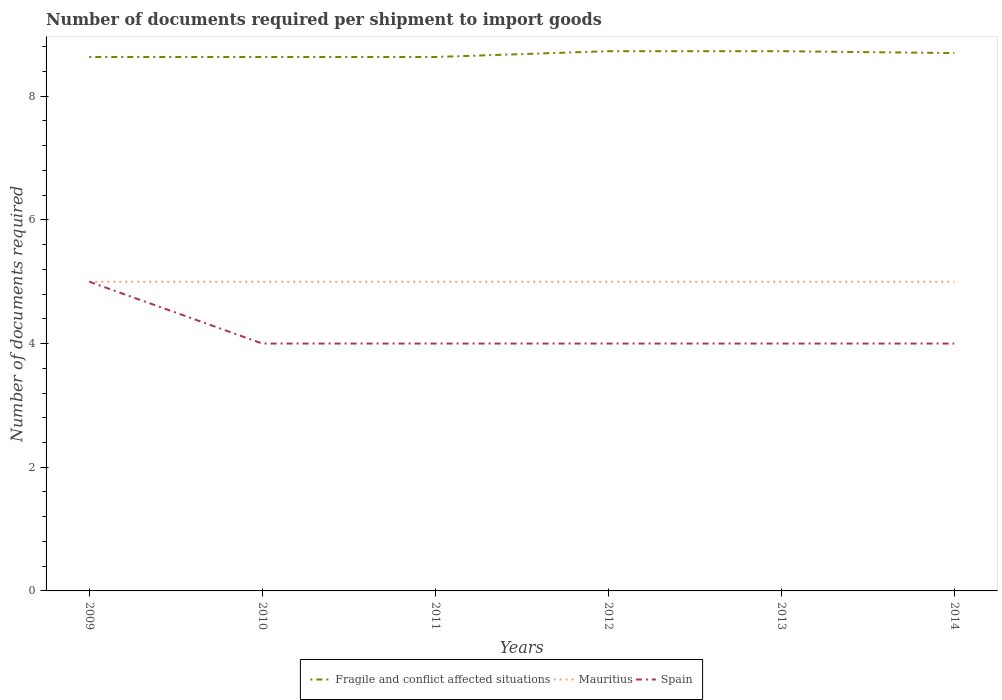How many different coloured lines are there?
Provide a succinct answer. 3. Across all years, what is the maximum number of documents required per shipment to import goods in Mauritius?
Your answer should be compact. 5. What is the difference between the highest and the second highest number of documents required per shipment to import goods in Mauritius?
Your answer should be compact. 0. What is the difference between the highest and the lowest number of documents required per shipment to import goods in Spain?
Provide a succinct answer. 1. How many years are there in the graph?
Make the answer very short. 6. Are the values on the major ticks of Y-axis written in scientific E-notation?
Your answer should be compact. No. Does the graph contain any zero values?
Offer a very short reply. No. Does the graph contain grids?
Offer a very short reply. No. How many legend labels are there?
Your response must be concise. 3. How are the legend labels stacked?
Provide a succinct answer. Horizontal. What is the title of the graph?
Your answer should be very brief. Number of documents required per shipment to import goods. What is the label or title of the X-axis?
Your response must be concise. Years. What is the label or title of the Y-axis?
Provide a succinct answer. Number of documents required. What is the Number of documents required in Fragile and conflict affected situations in 2009?
Provide a succinct answer. 8.63. What is the Number of documents required of Fragile and conflict affected situations in 2010?
Offer a terse response. 8.63. What is the Number of documents required of Spain in 2010?
Ensure brevity in your answer.  4. What is the Number of documents required in Fragile and conflict affected situations in 2011?
Offer a very short reply. 8.63. What is the Number of documents required of Mauritius in 2011?
Offer a terse response. 5. What is the Number of documents required of Fragile and conflict affected situations in 2012?
Offer a terse response. 8.73. What is the Number of documents required in Mauritius in 2012?
Your response must be concise. 5. What is the Number of documents required in Spain in 2012?
Offer a very short reply. 4. What is the Number of documents required of Fragile and conflict affected situations in 2013?
Offer a terse response. 8.73. What is the Number of documents required in Spain in 2013?
Offer a terse response. 4. What is the Number of documents required in Fragile and conflict affected situations in 2014?
Make the answer very short. 8.7. What is the Number of documents required of Spain in 2014?
Ensure brevity in your answer.  4. Across all years, what is the maximum Number of documents required in Fragile and conflict affected situations?
Ensure brevity in your answer.  8.73. Across all years, what is the maximum Number of documents required in Mauritius?
Provide a succinct answer. 5. Across all years, what is the minimum Number of documents required of Fragile and conflict affected situations?
Offer a very short reply. 8.63. What is the total Number of documents required in Fragile and conflict affected situations in the graph?
Your answer should be very brief. 52.05. What is the total Number of documents required of Mauritius in the graph?
Your answer should be compact. 30. What is the total Number of documents required in Spain in the graph?
Your answer should be very brief. 25. What is the difference between the Number of documents required in Mauritius in 2009 and that in 2010?
Provide a succinct answer. 0. What is the difference between the Number of documents required in Spain in 2009 and that in 2010?
Your answer should be compact. 1. What is the difference between the Number of documents required of Mauritius in 2009 and that in 2011?
Ensure brevity in your answer.  0. What is the difference between the Number of documents required in Fragile and conflict affected situations in 2009 and that in 2012?
Your answer should be compact. -0.09. What is the difference between the Number of documents required of Mauritius in 2009 and that in 2012?
Provide a succinct answer. 0. What is the difference between the Number of documents required of Spain in 2009 and that in 2012?
Give a very brief answer. 1. What is the difference between the Number of documents required of Fragile and conflict affected situations in 2009 and that in 2013?
Offer a very short reply. -0.09. What is the difference between the Number of documents required of Fragile and conflict affected situations in 2009 and that in 2014?
Provide a short and direct response. -0.06. What is the difference between the Number of documents required of Mauritius in 2010 and that in 2011?
Your response must be concise. 0. What is the difference between the Number of documents required in Spain in 2010 and that in 2011?
Make the answer very short. 0. What is the difference between the Number of documents required in Fragile and conflict affected situations in 2010 and that in 2012?
Make the answer very short. -0.09. What is the difference between the Number of documents required of Spain in 2010 and that in 2012?
Your answer should be very brief. 0. What is the difference between the Number of documents required in Fragile and conflict affected situations in 2010 and that in 2013?
Ensure brevity in your answer.  -0.09. What is the difference between the Number of documents required in Mauritius in 2010 and that in 2013?
Offer a very short reply. 0. What is the difference between the Number of documents required in Spain in 2010 and that in 2013?
Provide a succinct answer. 0. What is the difference between the Number of documents required of Fragile and conflict affected situations in 2010 and that in 2014?
Offer a very short reply. -0.06. What is the difference between the Number of documents required in Mauritius in 2010 and that in 2014?
Make the answer very short. 0. What is the difference between the Number of documents required of Spain in 2010 and that in 2014?
Offer a terse response. 0. What is the difference between the Number of documents required of Fragile and conflict affected situations in 2011 and that in 2012?
Your response must be concise. -0.09. What is the difference between the Number of documents required in Mauritius in 2011 and that in 2012?
Your answer should be compact. 0. What is the difference between the Number of documents required in Fragile and conflict affected situations in 2011 and that in 2013?
Your answer should be compact. -0.09. What is the difference between the Number of documents required in Mauritius in 2011 and that in 2013?
Ensure brevity in your answer.  0. What is the difference between the Number of documents required of Spain in 2011 and that in 2013?
Make the answer very short. 0. What is the difference between the Number of documents required in Fragile and conflict affected situations in 2011 and that in 2014?
Your response must be concise. -0.06. What is the difference between the Number of documents required in Mauritius in 2012 and that in 2013?
Ensure brevity in your answer.  0. What is the difference between the Number of documents required of Fragile and conflict affected situations in 2012 and that in 2014?
Give a very brief answer. 0.03. What is the difference between the Number of documents required in Mauritius in 2012 and that in 2014?
Offer a very short reply. 0. What is the difference between the Number of documents required of Fragile and conflict affected situations in 2013 and that in 2014?
Ensure brevity in your answer.  0.03. What is the difference between the Number of documents required of Mauritius in 2013 and that in 2014?
Make the answer very short. 0. What is the difference between the Number of documents required of Fragile and conflict affected situations in 2009 and the Number of documents required of Mauritius in 2010?
Your answer should be compact. 3.63. What is the difference between the Number of documents required in Fragile and conflict affected situations in 2009 and the Number of documents required in Spain in 2010?
Provide a succinct answer. 4.63. What is the difference between the Number of documents required in Mauritius in 2009 and the Number of documents required in Spain in 2010?
Make the answer very short. 1. What is the difference between the Number of documents required of Fragile and conflict affected situations in 2009 and the Number of documents required of Mauritius in 2011?
Your answer should be very brief. 3.63. What is the difference between the Number of documents required in Fragile and conflict affected situations in 2009 and the Number of documents required in Spain in 2011?
Your answer should be compact. 4.63. What is the difference between the Number of documents required in Mauritius in 2009 and the Number of documents required in Spain in 2011?
Your response must be concise. 1. What is the difference between the Number of documents required in Fragile and conflict affected situations in 2009 and the Number of documents required in Mauritius in 2012?
Ensure brevity in your answer.  3.63. What is the difference between the Number of documents required of Fragile and conflict affected situations in 2009 and the Number of documents required of Spain in 2012?
Provide a short and direct response. 4.63. What is the difference between the Number of documents required of Mauritius in 2009 and the Number of documents required of Spain in 2012?
Ensure brevity in your answer.  1. What is the difference between the Number of documents required of Fragile and conflict affected situations in 2009 and the Number of documents required of Mauritius in 2013?
Provide a succinct answer. 3.63. What is the difference between the Number of documents required in Fragile and conflict affected situations in 2009 and the Number of documents required in Spain in 2013?
Offer a very short reply. 4.63. What is the difference between the Number of documents required of Fragile and conflict affected situations in 2009 and the Number of documents required of Mauritius in 2014?
Your response must be concise. 3.63. What is the difference between the Number of documents required in Fragile and conflict affected situations in 2009 and the Number of documents required in Spain in 2014?
Make the answer very short. 4.63. What is the difference between the Number of documents required in Fragile and conflict affected situations in 2010 and the Number of documents required in Mauritius in 2011?
Make the answer very short. 3.63. What is the difference between the Number of documents required in Fragile and conflict affected situations in 2010 and the Number of documents required in Spain in 2011?
Ensure brevity in your answer.  4.63. What is the difference between the Number of documents required in Fragile and conflict affected situations in 2010 and the Number of documents required in Mauritius in 2012?
Your answer should be very brief. 3.63. What is the difference between the Number of documents required in Fragile and conflict affected situations in 2010 and the Number of documents required in Spain in 2012?
Ensure brevity in your answer.  4.63. What is the difference between the Number of documents required of Fragile and conflict affected situations in 2010 and the Number of documents required of Mauritius in 2013?
Your answer should be compact. 3.63. What is the difference between the Number of documents required of Fragile and conflict affected situations in 2010 and the Number of documents required of Spain in 2013?
Give a very brief answer. 4.63. What is the difference between the Number of documents required of Mauritius in 2010 and the Number of documents required of Spain in 2013?
Your answer should be very brief. 1. What is the difference between the Number of documents required of Fragile and conflict affected situations in 2010 and the Number of documents required of Mauritius in 2014?
Keep it short and to the point. 3.63. What is the difference between the Number of documents required in Fragile and conflict affected situations in 2010 and the Number of documents required in Spain in 2014?
Make the answer very short. 4.63. What is the difference between the Number of documents required of Mauritius in 2010 and the Number of documents required of Spain in 2014?
Offer a terse response. 1. What is the difference between the Number of documents required of Fragile and conflict affected situations in 2011 and the Number of documents required of Mauritius in 2012?
Provide a short and direct response. 3.63. What is the difference between the Number of documents required in Fragile and conflict affected situations in 2011 and the Number of documents required in Spain in 2012?
Provide a succinct answer. 4.63. What is the difference between the Number of documents required of Mauritius in 2011 and the Number of documents required of Spain in 2012?
Offer a very short reply. 1. What is the difference between the Number of documents required in Fragile and conflict affected situations in 2011 and the Number of documents required in Mauritius in 2013?
Your answer should be compact. 3.63. What is the difference between the Number of documents required of Fragile and conflict affected situations in 2011 and the Number of documents required of Spain in 2013?
Provide a succinct answer. 4.63. What is the difference between the Number of documents required of Mauritius in 2011 and the Number of documents required of Spain in 2013?
Ensure brevity in your answer.  1. What is the difference between the Number of documents required in Fragile and conflict affected situations in 2011 and the Number of documents required in Mauritius in 2014?
Offer a terse response. 3.63. What is the difference between the Number of documents required in Fragile and conflict affected situations in 2011 and the Number of documents required in Spain in 2014?
Your response must be concise. 4.63. What is the difference between the Number of documents required of Mauritius in 2011 and the Number of documents required of Spain in 2014?
Keep it short and to the point. 1. What is the difference between the Number of documents required in Fragile and conflict affected situations in 2012 and the Number of documents required in Mauritius in 2013?
Offer a very short reply. 3.73. What is the difference between the Number of documents required in Fragile and conflict affected situations in 2012 and the Number of documents required in Spain in 2013?
Your response must be concise. 4.73. What is the difference between the Number of documents required of Fragile and conflict affected situations in 2012 and the Number of documents required of Mauritius in 2014?
Give a very brief answer. 3.73. What is the difference between the Number of documents required of Fragile and conflict affected situations in 2012 and the Number of documents required of Spain in 2014?
Your response must be concise. 4.73. What is the difference between the Number of documents required of Mauritius in 2012 and the Number of documents required of Spain in 2014?
Your answer should be very brief. 1. What is the difference between the Number of documents required of Fragile and conflict affected situations in 2013 and the Number of documents required of Mauritius in 2014?
Your answer should be compact. 3.73. What is the difference between the Number of documents required in Fragile and conflict affected situations in 2013 and the Number of documents required in Spain in 2014?
Ensure brevity in your answer.  4.73. What is the difference between the Number of documents required in Mauritius in 2013 and the Number of documents required in Spain in 2014?
Provide a succinct answer. 1. What is the average Number of documents required in Fragile and conflict affected situations per year?
Keep it short and to the point. 8.68. What is the average Number of documents required in Spain per year?
Keep it short and to the point. 4.17. In the year 2009, what is the difference between the Number of documents required of Fragile and conflict affected situations and Number of documents required of Mauritius?
Provide a short and direct response. 3.63. In the year 2009, what is the difference between the Number of documents required of Fragile and conflict affected situations and Number of documents required of Spain?
Offer a terse response. 3.63. In the year 2009, what is the difference between the Number of documents required in Mauritius and Number of documents required in Spain?
Provide a short and direct response. 0. In the year 2010, what is the difference between the Number of documents required of Fragile and conflict affected situations and Number of documents required of Mauritius?
Offer a terse response. 3.63. In the year 2010, what is the difference between the Number of documents required of Fragile and conflict affected situations and Number of documents required of Spain?
Ensure brevity in your answer.  4.63. In the year 2010, what is the difference between the Number of documents required in Mauritius and Number of documents required in Spain?
Make the answer very short. 1. In the year 2011, what is the difference between the Number of documents required of Fragile and conflict affected situations and Number of documents required of Mauritius?
Offer a terse response. 3.63. In the year 2011, what is the difference between the Number of documents required in Fragile and conflict affected situations and Number of documents required in Spain?
Your answer should be compact. 4.63. In the year 2011, what is the difference between the Number of documents required of Mauritius and Number of documents required of Spain?
Provide a succinct answer. 1. In the year 2012, what is the difference between the Number of documents required of Fragile and conflict affected situations and Number of documents required of Mauritius?
Provide a short and direct response. 3.73. In the year 2012, what is the difference between the Number of documents required in Fragile and conflict affected situations and Number of documents required in Spain?
Ensure brevity in your answer.  4.73. In the year 2013, what is the difference between the Number of documents required of Fragile and conflict affected situations and Number of documents required of Mauritius?
Make the answer very short. 3.73. In the year 2013, what is the difference between the Number of documents required of Fragile and conflict affected situations and Number of documents required of Spain?
Give a very brief answer. 4.73. In the year 2013, what is the difference between the Number of documents required of Mauritius and Number of documents required of Spain?
Your answer should be very brief. 1. In the year 2014, what is the difference between the Number of documents required of Fragile and conflict affected situations and Number of documents required of Mauritius?
Provide a succinct answer. 3.7. In the year 2014, what is the difference between the Number of documents required of Fragile and conflict affected situations and Number of documents required of Spain?
Provide a succinct answer. 4.7. In the year 2014, what is the difference between the Number of documents required of Mauritius and Number of documents required of Spain?
Ensure brevity in your answer.  1. What is the ratio of the Number of documents required of Fragile and conflict affected situations in 2009 to that in 2010?
Make the answer very short. 1. What is the ratio of the Number of documents required of Spain in 2009 to that in 2010?
Offer a very short reply. 1.25. What is the ratio of the Number of documents required in Fragile and conflict affected situations in 2009 to that in 2011?
Ensure brevity in your answer.  1. What is the ratio of the Number of documents required of Mauritius in 2009 to that in 2011?
Offer a terse response. 1. What is the ratio of the Number of documents required in Spain in 2009 to that in 2011?
Your answer should be very brief. 1.25. What is the ratio of the Number of documents required in Mauritius in 2009 to that in 2012?
Provide a short and direct response. 1. What is the ratio of the Number of documents required in Mauritius in 2009 to that in 2013?
Ensure brevity in your answer.  1. What is the ratio of the Number of documents required in Mauritius in 2009 to that in 2014?
Your response must be concise. 1. What is the ratio of the Number of documents required of Mauritius in 2010 to that in 2011?
Make the answer very short. 1. What is the ratio of the Number of documents required of Spain in 2010 to that in 2011?
Offer a very short reply. 1. What is the ratio of the Number of documents required of Mauritius in 2010 to that in 2012?
Your answer should be compact. 1. What is the ratio of the Number of documents required of Mauritius in 2010 to that in 2013?
Your answer should be compact. 1. What is the ratio of the Number of documents required of Spain in 2010 to that in 2013?
Give a very brief answer. 1. What is the ratio of the Number of documents required of Mauritius in 2010 to that in 2014?
Provide a succinct answer. 1. What is the ratio of the Number of documents required of Spain in 2010 to that in 2014?
Your answer should be very brief. 1. What is the ratio of the Number of documents required in Fragile and conflict affected situations in 2011 to that in 2012?
Your answer should be compact. 0.99. What is the ratio of the Number of documents required of Spain in 2011 to that in 2012?
Provide a short and direct response. 1. What is the ratio of the Number of documents required of Mauritius in 2011 to that in 2013?
Offer a very short reply. 1. What is the ratio of the Number of documents required in Mauritius in 2011 to that in 2014?
Give a very brief answer. 1. What is the ratio of the Number of documents required of Spain in 2011 to that in 2014?
Keep it short and to the point. 1. What is the ratio of the Number of documents required of Mauritius in 2012 to that in 2013?
Offer a very short reply. 1. What is the ratio of the Number of documents required in Spain in 2012 to that in 2013?
Give a very brief answer. 1. What is the ratio of the Number of documents required in Mauritius in 2012 to that in 2014?
Keep it short and to the point. 1. What is the difference between the highest and the second highest Number of documents required in Fragile and conflict affected situations?
Keep it short and to the point. 0. What is the difference between the highest and the second highest Number of documents required of Mauritius?
Ensure brevity in your answer.  0. What is the difference between the highest and the lowest Number of documents required in Fragile and conflict affected situations?
Ensure brevity in your answer.  0.09. What is the difference between the highest and the lowest Number of documents required of Spain?
Offer a very short reply. 1. 